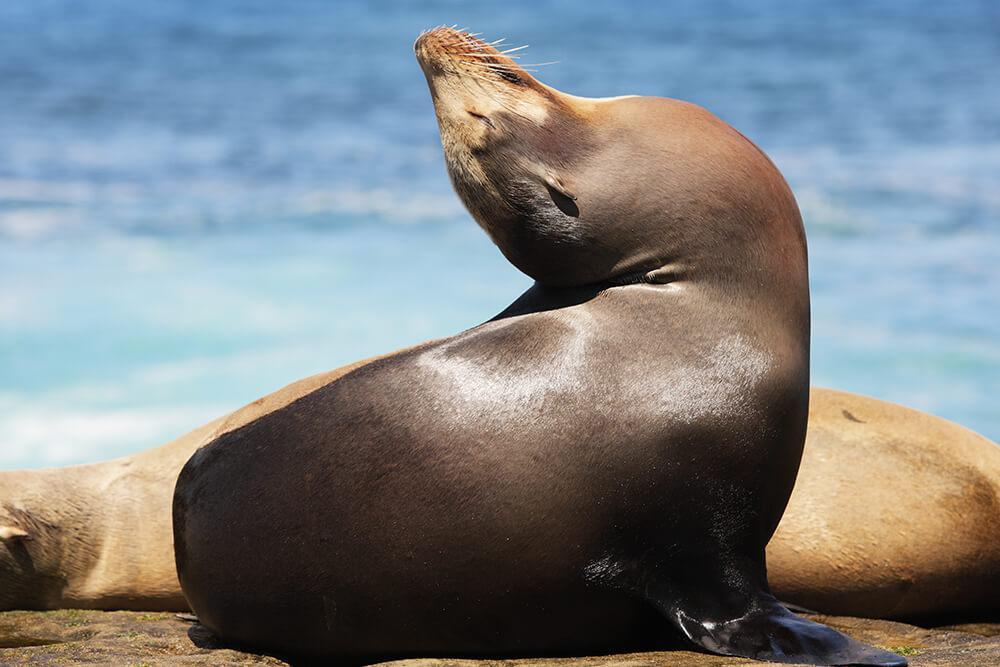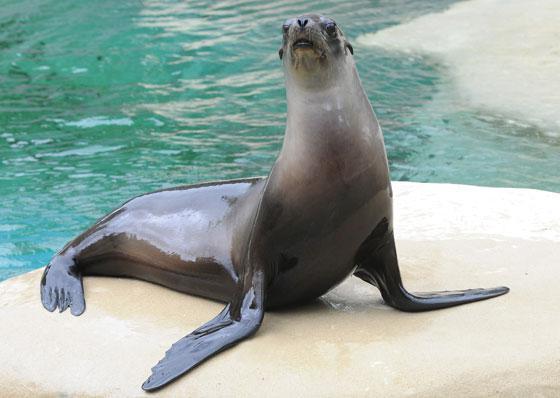The first image is the image on the left, the second image is the image on the right. Considering the images on both sides, is "The right image shows a seal and no other animal, posed on smooth rock in front of blue-green water." valid? Answer yes or no. Yes. The first image is the image on the left, the second image is the image on the right. For the images displayed, is the sentence "A single wet seal is sunning on a rock alone in the image on the right." factually correct? Answer yes or no. Yes. 